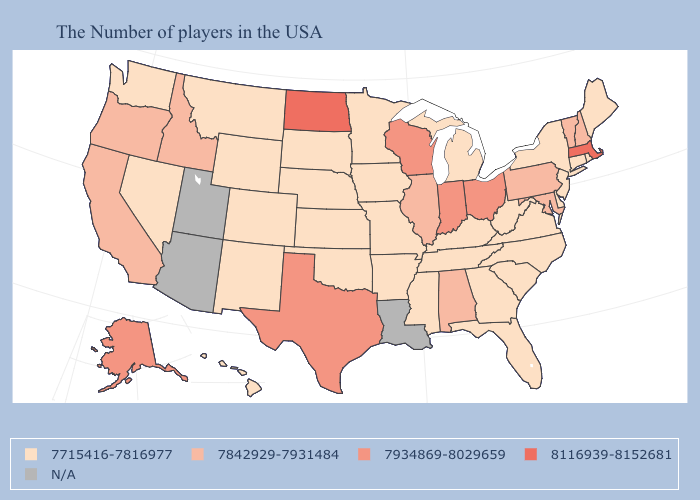Name the states that have a value in the range 7934869-8029659?
Quick response, please. Ohio, Indiana, Wisconsin, Texas, Alaska. How many symbols are there in the legend?
Give a very brief answer. 5. Does Alaska have the highest value in the West?
Short answer required. Yes. Which states have the lowest value in the USA?
Short answer required. Maine, Rhode Island, Connecticut, New York, New Jersey, Delaware, Virginia, North Carolina, South Carolina, West Virginia, Florida, Georgia, Michigan, Kentucky, Tennessee, Mississippi, Missouri, Arkansas, Minnesota, Iowa, Kansas, Nebraska, Oklahoma, South Dakota, Wyoming, Colorado, New Mexico, Montana, Nevada, Washington, Hawaii. Among the states that border Kentucky , which have the lowest value?
Keep it brief. Virginia, West Virginia, Tennessee, Missouri. Which states have the highest value in the USA?
Give a very brief answer. Massachusetts, North Dakota. Does Massachusetts have the highest value in the USA?
Give a very brief answer. Yes. What is the value of Mississippi?
Answer briefly. 7715416-7816977. Which states hav the highest value in the MidWest?
Be succinct. North Dakota. Name the states that have a value in the range 7934869-8029659?
Answer briefly. Ohio, Indiana, Wisconsin, Texas, Alaska. Name the states that have a value in the range 7842929-7931484?
Write a very short answer. New Hampshire, Vermont, Maryland, Pennsylvania, Alabama, Illinois, Idaho, California, Oregon. Name the states that have a value in the range 7842929-7931484?
Keep it brief. New Hampshire, Vermont, Maryland, Pennsylvania, Alabama, Illinois, Idaho, California, Oregon. What is the lowest value in the USA?
Write a very short answer. 7715416-7816977. 